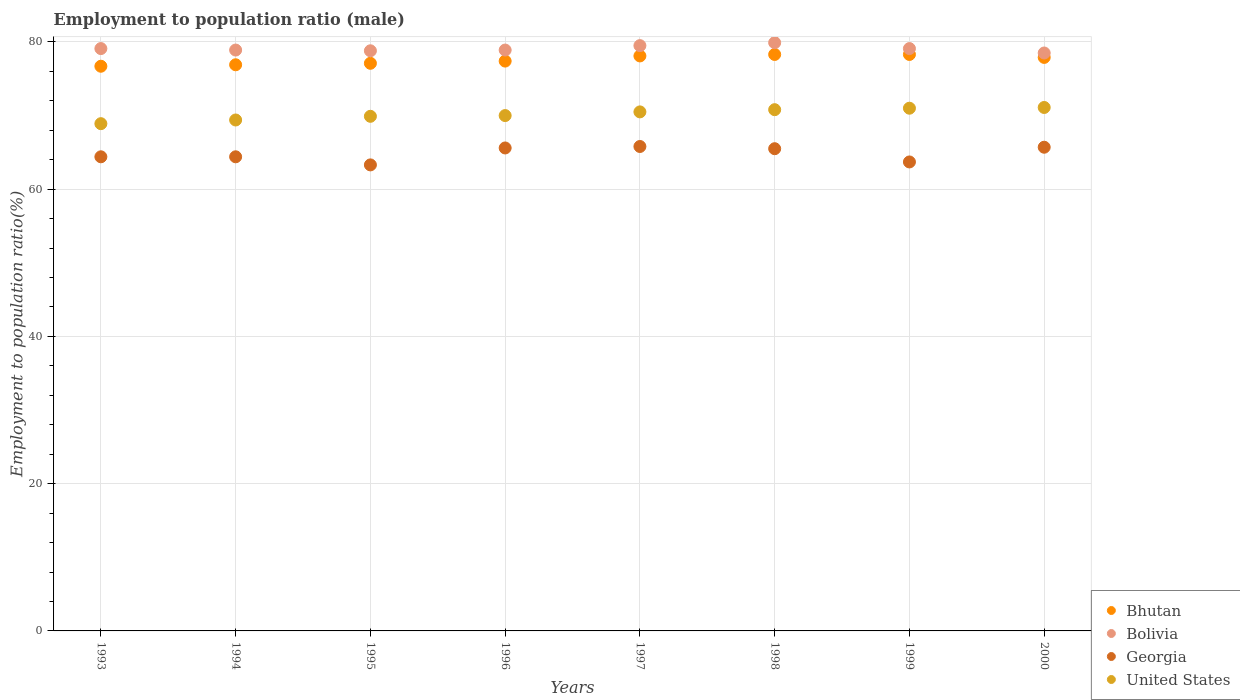How many different coloured dotlines are there?
Your answer should be compact. 4. What is the employment to population ratio in United States in 1996?
Your response must be concise. 70. Across all years, what is the maximum employment to population ratio in United States?
Your answer should be compact. 71.1. Across all years, what is the minimum employment to population ratio in Georgia?
Ensure brevity in your answer.  63.3. What is the total employment to population ratio in Bolivia in the graph?
Keep it short and to the point. 632.7. What is the difference between the employment to population ratio in Georgia in 1996 and that in 2000?
Offer a very short reply. -0.1. What is the difference between the employment to population ratio in United States in 1999 and the employment to population ratio in Bhutan in 1996?
Your answer should be very brief. -6.4. What is the average employment to population ratio in Bolivia per year?
Your answer should be very brief. 79.09. In the year 1996, what is the difference between the employment to population ratio in Bolivia and employment to population ratio in Georgia?
Your answer should be compact. 13.3. What is the ratio of the employment to population ratio in United States in 1996 to that in 2000?
Ensure brevity in your answer.  0.98. What is the difference between the highest and the second highest employment to population ratio in Bolivia?
Ensure brevity in your answer.  0.4. What is the difference between the highest and the lowest employment to population ratio in United States?
Keep it short and to the point. 2.2. Is it the case that in every year, the sum of the employment to population ratio in Bolivia and employment to population ratio in United States  is greater than the sum of employment to population ratio in Georgia and employment to population ratio in Bhutan?
Keep it short and to the point. Yes. Does the employment to population ratio in Bhutan monotonically increase over the years?
Offer a very short reply. No. Is the employment to population ratio in Bolivia strictly greater than the employment to population ratio in Bhutan over the years?
Provide a succinct answer. Yes. Is the employment to population ratio in United States strictly less than the employment to population ratio in Bhutan over the years?
Make the answer very short. Yes. How many dotlines are there?
Your answer should be compact. 4. How many years are there in the graph?
Provide a succinct answer. 8. Does the graph contain any zero values?
Make the answer very short. No. Where does the legend appear in the graph?
Provide a short and direct response. Bottom right. How many legend labels are there?
Provide a succinct answer. 4. How are the legend labels stacked?
Give a very brief answer. Vertical. What is the title of the graph?
Keep it short and to the point. Employment to population ratio (male). What is the Employment to population ratio(%) of Bhutan in 1993?
Keep it short and to the point. 76.7. What is the Employment to population ratio(%) in Bolivia in 1993?
Make the answer very short. 79.1. What is the Employment to population ratio(%) in Georgia in 1993?
Your answer should be compact. 64.4. What is the Employment to population ratio(%) in United States in 1993?
Your answer should be compact. 68.9. What is the Employment to population ratio(%) in Bhutan in 1994?
Your answer should be very brief. 76.9. What is the Employment to population ratio(%) in Bolivia in 1994?
Ensure brevity in your answer.  78.9. What is the Employment to population ratio(%) of Georgia in 1994?
Keep it short and to the point. 64.4. What is the Employment to population ratio(%) of United States in 1994?
Offer a very short reply. 69.4. What is the Employment to population ratio(%) of Bhutan in 1995?
Make the answer very short. 77.1. What is the Employment to population ratio(%) in Bolivia in 1995?
Offer a terse response. 78.8. What is the Employment to population ratio(%) of Georgia in 1995?
Offer a terse response. 63.3. What is the Employment to population ratio(%) in United States in 1995?
Your answer should be compact. 69.9. What is the Employment to population ratio(%) in Bhutan in 1996?
Keep it short and to the point. 77.4. What is the Employment to population ratio(%) of Bolivia in 1996?
Offer a terse response. 78.9. What is the Employment to population ratio(%) in Georgia in 1996?
Offer a very short reply. 65.6. What is the Employment to population ratio(%) of Bhutan in 1997?
Ensure brevity in your answer.  78.1. What is the Employment to population ratio(%) of Bolivia in 1997?
Provide a succinct answer. 79.5. What is the Employment to population ratio(%) of Georgia in 1997?
Give a very brief answer. 65.8. What is the Employment to population ratio(%) of United States in 1997?
Give a very brief answer. 70.5. What is the Employment to population ratio(%) of Bhutan in 1998?
Keep it short and to the point. 78.3. What is the Employment to population ratio(%) in Bolivia in 1998?
Your response must be concise. 79.9. What is the Employment to population ratio(%) in Georgia in 1998?
Make the answer very short. 65.5. What is the Employment to population ratio(%) of United States in 1998?
Your answer should be very brief. 70.8. What is the Employment to population ratio(%) in Bhutan in 1999?
Keep it short and to the point. 78.3. What is the Employment to population ratio(%) of Bolivia in 1999?
Give a very brief answer. 79.1. What is the Employment to population ratio(%) in Georgia in 1999?
Offer a very short reply. 63.7. What is the Employment to population ratio(%) in Bhutan in 2000?
Offer a terse response. 77.9. What is the Employment to population ratio(%) of Bolivia in 2000?
Give a very brief answer. 78.5. What is the Employment to population ratio(%) in Georgia in 2000?
Your answer should be compact. 65.7. What is the Employment to population ratio(%) of United States in 2000?
Provide a short and direct response. 71.1. Across all years, what is the maximum Employment to population ratio(%) in Bhutan?
Provide a succinct answer. 78.3. Across all years, what is the maximum Employment to population ratio(%) of Bolivia?
Provide a short and direct response. 79.9. Across all years, what is the maximum Employment to population ratio(%) in Georgia?
Offer a terse response. 65.8. Across all years, what is the maximum Employment to population ratio(%) in United States?
Offer a terse response. 71.1. Across all years, what is the minimum Employment to population ratio(%) of Bhutan?
Make the answer very short. 76.7. Across all years, what is the minimum Employment to population ratio(%) of Bolivia?
Offer a terse response. 78.5. Across all years, what is the minimum Employment to population ratio(%) in Georgia?
Offer a very short reply. 63.3. Across all years, what is the minimum Employment to population ratio(%) in United States?
Make the answer very short. 68.9. What is the total Employment to population ratio(%) of Bhutan in the graph?
Give a very brief answer. 620.7. What is the total Employment to population ratio(%) in Bolivia in the graph?
Your answer should be compact. 632.7. What is the total Employment to population ratio(%) in Georgia in the graph?
Your response must be concise. 518.4. What is the total Employment to population ratio(%) of United States in the graph?
Make the answer very short. 561.6. What is the difference between the Employment to population ratio(%) of Georgia in 1993 and that in 1994?
Give a very brief answer. 0. What is the difference between the Employment to population ratio(%) in United States in 1993 and that in 1994?
Give a very brief answer. -0.5. What is the difference between the Employment to population ratio(%) in Bolivia in 1993 and that in 1995?
Provide a short and direct response. 0.3. What is the difference between the Employment to population ratio(%) of United States in 1993 and that in 1995?
Keep it short and to the point. -1. What is the difference between the Employment to population ratio(%) of Bolivia in 1993 and that in 1996?
Offer a terse response. 0.2. What is the difference between the Employment to population ratio(%) of Georgia in 1993 and that in 1996?
Your response must be concise. -1.2. What is the difference between the Employment to population ratio(%) of United States in 1993 and that in 1996?
Your answer should be very brief. -1.1. What is the difference between the Employment to population ratio(%) of Bolivia in 1993 and that in 1997?
Your answer should be very brief. -0.4. What is the difference between the Employment to population ratio(%) of Bolivia in 1993 and that in 1998?
Offer a very short reply. -0.8. What is the difference between the Employment to population ratio(%) of Bhutan in 1993 and that in 1999?
Provide a succinct answer. -1.6. What is the difference between the Employment to population ratio(%) in Georgia in 1993 and that in 1999?
Give a very brief answer. 0.7. What is the difference between the Employment to population ratio(%) of Bolivia in 1993 and that in 2000?
Ensure brevity in your answer.  0.6. What is the difference between the Employment to population ratio(%) of United States in 1993 and that in 2000?
Make the answer very short. -2.2. What is the difference between the Employment to population ratio(%) in Bhutan in 1994 and that in 1995?
Offer a very short reply. -0.2. What is the difference between the Employment to population ratio(%) in Georgia in 1994 and that in 1995?
Ensure brevity in your answer.  1.1. What is the difference between the Employment to population ratio(%) of Bhutan in 1994 and that in 1996?
Keep it short and to the point. -0.5. What is the difference between the Employment to population ratio(%) in United States in 1994 and that in 1996?
Offer a very short reply. -0.6. What is the difference between the Employment to population ratio(%) of Bhutan in 1994 and that in 1997?
Offer a terse response. -1.2. What is the difference between the Employment to population ratio(%) in Georgia in 1994 and that in 1997?
Provide a succinct answer. -1.4. What is the difference between the Employment to population ratio(%) of Bolivia in 1994 and that in 1998?
Your answer should be very brief. -1. What is the difference between the Employment to population ratio(%) of Bhutan in 1994 and that in 1999?
Ensure brevity in your answer.  -1.4. What is the difference between the Employment to population ratio(%) of Bhutan in 1995 and that in 1996?
Provide a succinct answer. -0.3. What is the difference between the Employment to population ratio(%) of Bolivia in 1995 and that in 1996?
Keep it short and to the point. -0.1. What is the difference between the Employment to population ratio(%) in Georgia in 1995 and that in 1996?
Your answer should be very brief. -2.3. What is the difference between the Employment to population ratio(%) of Georgia in 1995 and that in 1997?
Your answer should be compact. -2.5. What is the difference between the Employment to population ratio(%) in United States in 1995 and that in 1998?
Keep it short and to the point. -0.9. What is the difference between the Employment to population ratio(%) of Bhutan in 1995 and that in 1999?
Your answer should be compact. -1.2. What is the difference between the Employment to population ratio(%) of Georgia in 1995 and that in 1999?
Your response must be concise. -0.4. What is the difference between the Employment to population ratio(%) of Bolivia in 1995 and that in 2000?
Keep it short and to the point. 0.3. What is the difference between the Employment to population ratio(%) of United States in 1995 and that in 2000?
Offer a terse response. -1.2. What is the difference between the Employment to population ratio(%) in Bhutan in 1996 and that in 1997?
Ensure brevity in your answer.  -0.7. What is the difference between the Employment to population ratio(%) of Bolivia in 1996 and that in 1997?
Provide a succinct answer. -0.6. What is the difference between the Employment to population ratio(%) of Georgia in 1996 and that in 1997?
Offer a very short reply. -0.2. What is the difference between the Employment to population ratio(%) of United States in 1996 and that in 1997?
Your response must be concise. -0.5. What is the difference between the Employment to population ratio(%) in Bolivia in 1996 and that in 1998?
Keep it short and to the point. -1. What is the difference between the Employment to population ratio(%) in Georgia in 1996 and that in 1998?
Offer a terse response. 0.1. What is the difference between the Employment to population ratio(%) in United States in 1996 and that in 1998?
Your response must be concise. -0.8. What is the difference between the Employment to population ratio(%) in Bolivia in 1996 and that in 1999?
Provide a succinct answer. -0.2. What is the difference between the Employment to population ratio(%) in Bolivia in 1996 and that in 2000?
Your response must be concise. 0.4. What is the difference between the Employment to population ratio(%) of United States in 1996 and that in 2000?
Provide a succinct answer. -1.1. What is the difference between the Employment to population ratio(%) of Bolivia in 1997 and that in 1998?
Your response must be concise. -0.4. What is the difference between the Employment to population ratio(%) of Bhutan in 1997 and that in 1999?
Give a very brief answer. -0.2. What is the difference between the Employment to population ratio(%) in Georgia in 1997 and that in 2000?
Provide a succinct answer. 0.1. What is the difference between the Employment to population ratio(%) in United States in 1997 and that in 2000?
Ensure brevity in your answer.  -0.6. What is the difference between the Employment to population ratio(%) of Bolivia in 1998 and that in 1999?
Your response must be concise. 0.8. What is the difference between the Employment to population ratio(%) of Georgia in 1998 and that in 1999?
Give a very brief answer. 1.8. What is the difference between the Employment to population ratio(%) of United States in 1998 and that in 2000?
Keep it short and to the point. -0.3. What is the difference between the Employment to population ratio(%) of Bhutan in 1999 and that in 2000?
Offer a terse response. 0.4. What is the difference between the Employment to population ratio(%) of Bolivia in 1999 and that in 2000?
Provide a succinct answer. 0.6. What is the difference between the Employment to population ratio(%) in United States in 1999 and that in 2000?
Your answer should be very brief. -0.1. What is the difference between the Employment to population ratio(%) in Bhutan in 1993 and the Employment to population ratio(%) in Georgia in 1994?
Keep it short and to the point. 12.3. What is the difference between the Employment to population ratio(%) of Bhutan in 1993 and the Employment to population ratio(%) of United States in 1994?
Provide a short and direct response. 7.3. What is the difference between the Employment to population ratio(%) of Georgia in 1993 and the Employment to population ratio(%) of United States in 1994?
Offer a terse response. -5. What is the difference between the Employment to population ratio(%) of Bhutan in 1993 and the Employment to population ratio(%) of Georgia in 1995?
Make the answer very short. 13.4. What is the difference between the Employment to population ratio(%) of Bolivia in 1993 and the Employment to population ratio(%) of Georgia in 1995?
Make the answer very short. 15.8. What is the difference between the Employment to population ratio(%) in Georgia in 1993 and the Employment to population ratio(%) in United States in 1995?
Your answer should be compact. -5.5. What is the difference between the Employment to population ratio(%) of Bhutan in 1993 and the Employment to population ratio(%) of Bolivia in 1996?
Your answer should be very brief. -2.2. What is the difference between the Employment to population ratio(%) in Bhutan in 1993 and the Employment to population ratio(%) in Georgia in 1996?
Provide a short and direct response. 11.1. What is the difference between the Employment to population ratio(%) in Bhutan in 1993 and the Employment to population ratio(%) in United States in 1996?
Give a very brief answer. 6.7. What is the difference between the Employment to population ratio(%) in Bolivia in 1993 and the Employment to population ratio(%) in United States in 1996?
Your answer should be compact. 9.1. What is the difference between the Employment to population ratio(%) of Bhutan in 1993 and the Employment to population ratio(%) of Bolivia in 1997?
Offer a very short reply. -2.8. What is the difference between the Employment to population ratio(%) of Bhutan in 1993 and the Employment to population ratio(%) of Georgia in 1997?
Give a very brief answer. 10.9. What is the difference between the Employment to population ratio(%) in Bhutan in 1993 and the Employment to population ratio(%) in United States in 1997?
Keep it short and to the point. 6.2. What is the difference between the Employment to population ratio(%) of Bolivia in 1993 and the Employment to population ratio(%) of United States in 1997?
Keep it short and to the point. 8.6. What is the difference between the Employment to population ratio(%) of Georgia in 1993 and the Employment to population ratio(%) of United States in 1997?
Provide a succinct answer. -6.1. What is the difference between the Employment to population ratio(%) of Bhutan in 1993 and the Employment to population ratio(%) of Georgia in 1998?
Give a very brief answer. 11.2. What is the difference between the Employment to population ratio(%) of Bhutan in 1993 and the Employment to population ratio(%) of United States in 1998?
Your answer should be compact. 5.9. What is the difference between the Employment to population ratio(%) in Bolivia in 1993 and the Employment to population ratio(%) in Georgia in 1998?
Provide a short and direct response. 13.6. What is the difference between the Employment to population ratio(%) of Bolivia in 1993 and the Employment to population ratio(%) of United States in 1998?
Provide a succinct answer. 8.3. What is the difference between the Employment to population ratio(%) of Bhutan in 1993 and the Employment to population ratio(%) of Bolivia in 1999?
Your response must be concise. -2.4. What is the difference between the Employment to population ratio(%) of Bhutan in 1993 and the Employment to population ratio(%) of United States in 1999?
Your answer should be very brief. 5.7. What is the difference between the Employment to population ratio(%) in Bolivia in 1993 and the Employment to population ratio(%) in Georgia in 1999?
Offer a terse response. 15.4. What is the difference between the Employment to population ratio(%) in Georgia in 1993 and the Employment to population ratio(%) in United States in 1999?
Provide a succinct answer. -6.6. What is the difference between the Employment to population ratio(%) in Bhutan in 1993 and the Employment to population ratio(%) in Bolivia in 2000?
Your answer should be very brief. -1.8. What is the difference between the Employment to population ratio(%) in Bhutan in 1993 and the Employment to population ratio(%) in Georgia in 2000?
Provide a succinct answer. 11. What is the difference between the Employment to population ratio(%) of Bhutan in 1993 and the Employment to population ratio(%) of United States in 2000?
Make the answer very short. 5.6. What is the difference between the Employment to population ratio(%) in Bolivia in 1993 and the Employment to population ratio(%) in Georgia in 2000?
Give a very brief answer. 13.4. What is the difference between the Employment to population ratio(%) of Georgia in 1993 and the Employment to population ratio(%) of United States in 2000?
Your answer should be compact. -6.7. What is the difference between the Employment to population ratio(%) in Bhutan in 1994 and the Employment to population ratio(%) in Bolivia in 1995?
Your answer should be very brief. -1.9. What is the difference between the Employment to population ratio(%) in Bhutan in 1994 and the Employment to population ratio(%) in Georgia in 1995?
Offer a terse response. 13.6. What is the difference between the Employment to population ratio(%) in Bhutan in 1994 and the Employment to population ratio(%) in United States in 1995?
Provide a short and direct response. 7. What is the difference between the Employment to population ratio(%) in Bolivia in 1994 and the Employment to population ratio(%) in Georgia in 1995?
Keep it short and to the point. 15.6. What is the difference between the Employment to population ratio(%) in Bolivia in 1994 and the Employment to population ratio(%) in United States in 1995?
Provide a succinct answer. 9. What is the difference between the Employment to population ratio(%) in Bhutan in 1994 and the Employment to population ratio(%) in Bolivia in 1996?
Provide a succinct answer. -2. What is the difference between the Employment to population ratio(%) in Bhutan in 1994 and the Employment to population ratio(%) in Georgia in 1996?
Give a very brief answer. 11.3. What is the difference between the Employment to population ratio(%) in Bhutan in 1994 and the Employment to population ratio(%) in United States in 1996?
Make the answer very short. 6.9. What is the difference between the Employment to population ratio(%) in Bhutan in 1994 and the Employment to population ratio(%) in Bolivia in 1997?
Your response must be concise. -2.6. What is the difference between the Employment to population ratio(%) in Bhutan in 1994 and the Employment to population ratio(%) in Georgia in 1997?
Your answer should be compact. 11.1. What is the difference between the Employment to population ratio(%) of Bhutan in 1994 and the Employment to population ratio(%) of United States in 1997?
Offer a terse response. 6.4. What is the difference between the Employment to population ratio(%) in Bolivia in 1994 and the Employment to population ratio(%) in United States in 1997?
Keep it short and to the point. 8.4. What is the difference between the Employment to population ratio(%) of Bhutan in 1994 and the Employment to population ratio(%) of Georgia in 1998?
Your answer should be very brief. 11.4. What is the difference between the Employment to population ratio(%) in Georgia in 1994 and the Employment to population ratio(%) in United States in 1998?
Offer a very short reply. -6.4. What is the difference between the Employment to population ratio(%) of Bhutan in 1994 and the Employment to population ratio(%) of Bolivia in 1999?
Keep it short and to the point. -2.2. What is the difference between the Employment to population ratio(%) in Bhutan in 1994 and the Employment to population ratio(%) in Georgia in 1999?
Your answer should be compact. 13.2. What is the difference between the Employment to population ratio(%) of Bhutan in 1994 and the Employment to population ratio(%) of United States in 1999?
Provide a short and direct response. 5.9. What is the difference between the Employment to population ratio(%) of Bolivia in 1994 and the Employment to population ratio(%) of Georgia in 1999?
Your response must be concise. 15.2. What is the difference between the Employment to population ratio(%) in Bhutan in 1994 and the Employment to population ratio(%) in Bolivia in 2000?
Ensure brevity in your answer.  -1.6. What is the difference between the Employment to population ratio(%) in Bhutan in 1994 and the Employment to population ratio(%) in United States in 2000?
Give a very brief answer. 5.8. What is the difference between the Employment to population ratio(%) in Bolivia in 1994 and the Employment to population ratio(%) in Georgia in 2000?
Offer a very short reply. 13.2. What is the difference between the Employment to population ratio(%) in Georgia in 1994 and the Employment to population ratio(%) in United States in 2000?
Provide a succinct answer. -6.7. What is the difference between the Employment to population ratio(%) of Bhutan in 1995 and the Employment to population ratio(%) of Georgia in 1996?
Your answer should be very brief. 11.5. What is the difference between the Employment to population ratio(%) of Bolivia in 1995 and the Employment to population ratio(%) of United States in 1996?
Your answer should be very brief. 8.8. What is the difference between the Employment to population ratio(%) of Georgia in 1995 and the Employment to population ratio(%) of United States in 1996?
Your answer should be compact. -6.7. What is the difference between the Employment to population ratio(%) of Bhutan in 1995 and the Employment to population ratio(%) of Georgia in 1997?
Your answer should be very brief. 11.3. What is the difference between the Employment to population ratio(%) in Bhutan in 1995 and the Employment to population ratio(%) in United States in 1998?
Give a very brief answer. 6.3. What is the difference between the Employment to population ratio(%) of Bolivia in 1995 and the Employment to population ratio(%) of United States in 1998?
Your answer should be compact. 8. What is the difference between the Employment to population ratio(%) in Bolivia in 1995 and the Employment to population ratio(%) in United States in 1999?
Provide a succinct answer. 7.8. What is the difference between the Employment to population ratio(%) of Georgia in 1995 and the Employment to population ratio(%) of United States in 1999?
Provide a succinct answer. -7.7. What is the difference between the Employment to population ratio(%) of Bhutan in 1995 and the Employment to population ratio(%) of United States in 2000?
Give a very brief answer. 6. What is the difference between the Employment to population ratio(%) in Bolivia in 1995 and the Employment to population ratio(%) in Georgia in 2000?
Your answer should be very brief. 13.1. What is the difference between the Employment to population ratio(%) in Bolivia in 1995 and the Employment to population ratio(%) in United States in 2000?
Keep it short and to the point. 7.7. What is the difference between the Employment to population ratio(%) of Georgia in 1995 and the Employment to population ratio(%) of United States in 2000?
Provide a short and direct response. -7.8. What is the difference between the Employment to population ratio(%) in Bhutan in 1996 and the Employment to population ratio(%) in United States in 1997?
Keep it short and to the point. 6.9. What is the difference between the Employment to population ratio(%) in Bolivia in 1996 and the Employment to population ratio(%) in Georgia in 1997?
Ensure brevity in your answer.  13.1. What is the difference between the Employment to population ratio(%) of Bolivia in 1996 and the Employment to population ratio(%) of United States in 1997?
Offer a terse response. 8.4. What is the difference between the Employment to population ratio(%) of Bhutan in 1996 and the Employment to population ratio(%) of United States in 1998?
Provide a succinct answer. 6.6. What is the difference between the Employment to population ratio(%) in Bolivia in 1996 and the Employment to population ratio(%) in Georgia in 1998?
Your response must be concise. 13.4. What is the difference between the Employment to population ratio(%) of Bolivia in 1996 and the Employment to population ratio(%) of United States in 1998?
Give a very brief answer. 8.1. What is the difference between the Employment to population ratio(%) in Bhutan in 1996 and the Employment to population ratio(%) in Bolivia in 1999?
Give a very brief answer. -1.7. What is the difference between the Employment to population ratio(%) of Bhutan in 1996 and the Employment to population ratio(%) of Georgia in 1999?
Your answer should be compact. 13.7. What is the difference between the Employment to population ratio(%) in Bolivia in 1996 and the Employment to population ratio(%) in United States in 1999?
Provide a short and direct response. 7.9. What is the difference between the Employment to population ratio(%) of Georgia in 1996 and the Employment to population ratio(%) of United States in 1999?
Your answer should be compact. -5.4. What is the difference between the Employment to population ratio(%) of Bhutan in 1996 and the Employment to population ratio(%) of Bolivia in 2000?
Give a very brief answer. -1.1. What is the difference between the Employment to population ratio(%) in Bhutan in 1996 and the Employment to population ratio(%) in United States in 2000?
Provide a succinct answer. 6.3. What is the difference between the Employment to population ratio(%) in Bolivia in 1996 and the Employment to population ratio(%) in Georgia in 2000?
Your response must be concise. 13.2. What is the difference between the Employment to population ratio(%) in Georgia in 1996 and the Employment to population ratio(%) in United States in 2000?
Your answer should be very brief. -5.5. What is the difference between the Employment to population ratio(%) of Bhutan in 1997 and the Employment to population ratio(%) of Bolivia in 1998?
Your answer should be very brief. -1.8. What is the difference between the Employment to population ratio(%) in Bolivia in 1997 and the Employment to population ratio(%) in Georgia in 1998?
Provide a short and direct response. 14. What is the difference between the Employment to population ratio(%) of Bolivia in 1997 and the Employment to population ratio(%) of United States in 1998?
Provide a short and direct response. 8.7. What is the difference between the Employment to population ratio(%) in Bhutan in 1997 and the Employment to population ratio(%) in Bolivia in 1999?
Your answer should be compact. -1. What is the difference between the Employment to population ratio(%) of Bhutan in 1997 and the Employment to population ratio(%) of Georgia in 1999?
Your answer should be compact. 14.4. What is the difference between the Employment to population ratio(%) of Bhutan in 1997 and the Employment to population ratio(%) of United States in 1999?
Your answer should be very brief. 7.1. What is the difference between the Employment to population ratio(%) in Bolivia in 1997 and the Employment to population ratio(%) in United States in 1999?
Keep it short and to the point. 8.5. What is the difference between the Employment to population ratio(%) in Georgia in 1997 and the Employment to population ratio(%) in United States in 1999?
Make the answer very short. -5.2. What is the difference between the Employment to population ratio(%) in Bhutan in 1997 and the Employment to population ratio(%) in Bolivia in 2000?
Provide a short and direct response. -0.4. What is the difference between the Employment to population ratio(%) in Bhutan in 1997 and the Employment to population ratio(%) in Georgia in 2000?
Offer a very short reply. 12.4. What is the difference between the Employment to population ratio(%) in Bhutan in 1997 and the Employment to population ratio(%) in United States in 2000?
Give a very brief answer. 7. What is the difference between the Employment to population ratio(%) of Bolivia in 1997 and the Employment to population ratio(%) of United States in 2000?
Your answer should be very brief. 8.4. What is the difference between the Employment to population ratio(%) in Georgia in 1997 and the Employment to population ratio(%) in United States in 2000?
Provide a succinct answer. -5.3. What is the difference between the Employment to population ratio(%) of Bhutan in 1998 and the Employment to population ratio(%) of Georgia in 1999?
Ensure brevity in your answer.  14.6. What is the difference between the Employment to population ratio(%) in Bhutan in 1998 and the Employment to population ratio(%) in United States in 1999?
Provide a succinct answer. 7.3. What is the difference between the Employment to population ratio(%) of Bolivia in 1998 and the Employment to population ratio(%) of Georgia in 1999?
Give a very brief answer. 16.2. What is the difference between the Employment to population ratio(%) of Bolivia in 1998 and the Employment to population ratio(%) of United States in 1999?
Offer a very short reply. 8.9. What is the difference between the Employment to population ratio(%) of Bhutan in 1998 and the Employment to population ratio(%) of Bolivia in 2000?
Your answer should be compact. -0.2. What is the difference between the Employment to population ratio(%) in Bhutan in 1998 and the Employment to population ratio(%) in United States in 2000?
Provide a short and direct response. 7.2. What is the difference between the Employment to population ratio(%) in Bolivia in 1998 and the Employment to population ratio(%) in United States in 2000?
Offer a terse response. 8.8. What is the difference between the Employment to population ratio(%) of Bhutan in 1999 and the Employment to population ratio(%) of Bolivia in 2000?
Keep it short and to the point. -0.2. What is the difference between the Employment to population ratio(%) of Bhutan in 1999 and the Employment to population ratio(%) of United States in 2000?
Ensure brevity in your answer.  7.2. What is the difference between the Employment to population ratio(%) in Bolivia in 1999 and the Employment to population ratio(%) in United States in 2000?
Your answer should be compact. 8. What is the difference between the Employment to population ratio(%) of Georgia in 1999 and the Employment to population ratio(%) of United States in 2000?
Provide a succinct answer. -7.4. What is the average Employment to population ratio(%) of Bhutan per year?
Your response must be concise. 77.59. What is the average Employment to population ratio(%) in Bolivia per year?
Provide a short and direct response. 79.09. What is the average Employment to population ratio(%) of Georgia per year?
Provide a short and direct response. 64.8. What is the average Employment to population ratio(%) in United States per year?
Give a very brief answer. 70.2. In the year 1993, what is the difference between the Employment to population ratio(%) in Bhutan and Employment to population ratio(%) in Bolivia?
Offer a very short reply. -2.4. In the year 1993, what is the difference between the Employment to population ratio(%) of Bhutan and Employment to population ratio(%) of United States?
Offer a very short reply. 7.8. In the year 1993, what is the difference between the Employment to population ratio(%) in Bolivia and Employment to population ratio(%) in United States?
Make the answer very short. 10.2. In the year 1993, what is the difference between the Employment to population ratio(%) in Georgia and Employment to population ratio(%) in United States?
Make the answer very short. -4.5. In the year 1994, what is the difference between the Employment to population ratio(%) of Bolivia and Employment to population ratio(%) of Georgia?
Keep it short and to the point. 14.5. In the year 1994, what is the difference between the Employment to population ratio(%) of Georgia and Employment to population ratio(%) of United States?
Your answer should be very brief. -5. In the year 1995, what is the difference between the Employment to population ratio(%) in Bhutan and Employment to population ratio(%) in Bolivia?
Provide a short and direct response. -1.7. In the year 1995, what is the difference between the Employment to population ratio(%) in Bhutan and Employment to population ratio(%) in United States?
Provide a short and direct response. 7.2. In the year 1996, what is the difference between the Employment to population ratio(%) of Bhutan and Employment to population ratio(%) of Georgia?
Give a very brief answer. 11.8. In the year 1996, what is the difference between the Employment to population ratio(%) of Bolivia and Employment to population ratio(%) of United States?
Keep it short and to the point. 8.9. In the year 1997, what is the difference between the Employment to population ratio(%) of Bhutan and Employment to population ratio(%) of Bolivia?
Provide a succinct answer. -1.4. In the year 1997, what is the difference between the Employment to population ratio(%) of Bhutan and Employment to population ratio(%) of Georgia?
Ensure brevity in your answer.  12.3. In the year 1997, what is the difference between the Employment to population ratio(%) in Bolivia and Employment to population ratio(%) in United States?
Ensure brevity in your answer.  9. In the year 1998, what is the difference between the Employment to population ratio(%) of Bhutan and Employment to population ratio(%) of Bolivia?
Make the answer very short. -1.6. In the year 1998, what is the difference between the Employment to population ratio(%) in Bolivia and Employment to population ratio(%) in Georgia?
Give a very brief answer. 14.4. In the year 1998, what is the difference between the Employment to population ratio(%) of Georgia and Employment to population ratio(%) of United States?
Your response must be concise. -5.3. In the year 1999, what is the difference between the Employment to population ratio(%) in Bhutan and Employment to population ratio(%) in United States?
Make the answer very short. 7.3. In the year 1999, what is the difference between the Employment to population ratio(%) in Bolivia and Employment to population ratio(%) in United States?
Your answer should be compact. 8.1. In the year 1999, what is the difference between the Employment to population ratio(%) of Georgia and Employment to population ratio(%) of United States?
Make the answer very short. -7.3. In the year 2000, what is the difference between the Employment to population ratio(%) in Bhutan and Employment to population ratio(%) in Georgia?
Offer a very short reply. 12.2. In the year 2000, what is the difference between the Employment to population ratio(%) of Bhutan and Employment to population ratio(%) of United States?
Your answer should be compact. 6.8. In the year 2000, what is the difference between the Employment to population ratio(%) of Bolivia and Employment to population ratio(%) of United States?
Keep it short and to the point. 7.4. In the year 2000, what is the difference between the Employment to population ratio(%) in Georgia and Employment to population ratio(%) in United States?
Offer a very short reply. -5.4. What is the ratio of the Employment to population ratio(%) of Bolivia in 1993 to that in 1994?
Your answer should be very brief. 1. What is the ratio of the Employment to population ratio(%) in United States in 1993 to that in 1994?
Provide a short and direct response. 0.99. What is the ratio of the Employment to population ratio(%) in Bhutan in 1993 to that in 1995?
Provide a succinct answer. 0.99. What is the ratio of the Employment to population ratio(%) of Georgia in 1993 to that in 1995?
Provide a short and direct response. 1.02. What is the ratio of the Employment to population ratio(%) in United States in 1993 to that in 1995?
Offer a terse response. 0.99. What is the ratio of the Employment to population ratio(%) of Bhutan in 1993 to that in 1996?
Give a very brief answer. 0.99. What is the ratio of the Employment to population ratio(%) in Georgia in 1993 to that in 1996?
Provide a succinct answer. 0.98. What is the ratio of the Employment to population ratio(%) in United States in 1993 to that in 1996?
Your response must be concise. 0.98. What is the ratio of the Employment to population ratio(%) in Bhutan in 1993 to that in 1997?
Your response must be concise. 0.98. What is the ratio of the Employment to population ratio(%) of Bolivia in 1993 to that in 1997?
Ensure brevity in your answer.  0.99. What is the ratio of the Employment to population ratio(%) in Georgia in 1993 to that in 1997?
Ensure brevity in your answer.  0.98. What is the ratio of the Employment to population ratio(%) in United States in 1993 to that in 1997?
Your answer should be compact. 0.98. What is the ratio of the Employment to population ratio(%) of Bhutan in 1993 to that in 1998?
Offer a terse response. 0.98. What is the ratio of the Employment to population ratio(%) in Georgia in 1993 to that in 1998?
Your answer should be very brief. 0.98. What is the ratio of the Employment to population ratio(%) in United States in 1993 to that in 1998?
Keep it short and to the point. 0.97. What is the ratio of the Employment to population ratio(%) in Bhutan in 1993 to that in 1999?
Ensure brevity in your answer.  0.98. What is the ratio of the Employment to population ratio(%) of Bolivia in 1993 to that in 1999?
Your response must be concise. 1. What is the ratio of the Employment to population ratio(%) of United States in 1993 to that in 1999?
Provide a short and direct response. 0.97. What is the ratio of the Employment to population ratio(%) of Bhutan in 1993 to that in 2000?
Provide a short and direct response. 0.98. What is the ratio of the Employment to population ratio(%) of Bolivia in 1993 to that in 2000?
Give a very brief answer. 1.01. What is the ratio of the Employment to population ratio(%) in Georgia in 1993 to that in 2000?
Provide a short and direct response. 0.98. What is the ratio of the Employment to population ratio(%) in United States in 1993 to that in 2000?
Ensure brevity in your answer.  0.97. What is the ratio of the Employment to population ratio(%) of Georgia in 1994 to that in 1995?
Make the answer very short. 1.02. What is the ratio of the Employment to population ratio(%) in United States in 1994 to that in 1995?
Offer a terse response. 0.99. What is the ratio of the Employment to population ratio(%) of Bhutan in 1994 to that in 1996?
Ensure brevity in your answer.  0.99. What is the ratio of the Employment to population ratio(%) in Bolivia in 1994 to that in 1996?
Give a very brief answer. 1. What is the ratio of the Employment to population ratio(%) in Georgia in 1994 to that in 1996?
Give a very brief answer. 0.98. What is the ratio of the Employment to population ratio(%) of United States in 1994 to that in 1996?
Your answer should be compact. 0.99. What is the ratio of the Employment to population ratio(%) of Bhutan in 1994 to that in 1997?
Provide a succinct answer. 0.98. What is the ratio of the Employment to population ratio(%) of Georgia in 1994 to that in 1997?
Ensure brevity in your answer.  0.98. What is the ratio of the Employment to population ratio(%) in United States in 1994 to that in 1997?
Your answer should be compact. 0.98. What is the ratio of the Employment to population ratio(%) of Bhutan in 1994 to that in 1998?
Give a very brief answer. 0.98. What is the ratio of the Employment to population ratio(%) of Bolivia in 1994 to that in 1998?
Your answer should be compact. 0.99. What is the ratio of the Employment to population ratio(%) in Georgia in 1994 to that in 1998?
Offer a very short reply. 0.98. What is the ratio of the Employment to population ratio(%) in United States in 1994 to that in 1998?
Make the answer very short. 0.98. What is the ratio of the Employment to population ratio(%) of Bhutan in 1994 to that in 1999?
Provide a short and direct response. 0.98. What is the ratio of the Employment to population ratio(%) of United States in 1994 to that in 1999?
Your answer should be compact. 0.98. What is the ratio of the Employment to population ratio(%) in Bhutan in 1994 to that in 2000?
Make the answer very short. 0.99. What is the ratio of the Employment to population ratio(%) in Bolivia in 1994 to that in 2000?
Provide a short and direct response. 1.01. What is the ratio of the Employment to population ratio(%) in Georgia in 1994 to that in 2000?
Your answer should be compact. 0.98. What is the ratio of the Employment to population ratio(%) of United States in 1994 to that in 2000?
Provide a succinct answer. 0.98. What is the ratio of the Employment to population ratio(%) in Georgia in 1995 to that in 1996?
Keep it short and to the point. 0.96. What is the ratio of the Employment to population ratio(%) in Bhutan in 1995 to that in 1997?
Provide a short and direct response. 0.99. What is the ratio of the Employment to population ratio(%) in Bolivia in 1995 to that in 1997?
Keep it short and to the point. 0.99. What is the ratio of the Employment to population ratio(%) of Georgia in 1995 to that in 1997?
Keep it short and to the point. 0.96. What is the ratio of the Employment to population ratio(%) in United States in 1995 to that in 1997?
Your response must be concise. 0.99. What is the ratio of the Employment to population ratio(%) of Bhutan in 1995 to that in 1998?
Give a very brief answer. 0.98. What is the ratio of the Employment to population ratio(%) of Bolivia in 1995 to that in 1998?
Your answer should be compact. 0.99. What is the ratio of the Employment to population ratio(%) in Georgia in 1995 to that in 1998?
Offer a terse response. 0.97. What is the ratio of the Employment to population ratio(%) in United States in 1995 to that in 1998?
Provide a succinct answer. 0.99. What is the ratio of the Employment to population ratio(%) in Bhutan in 1995 to that in 1999?
Your response must be concise. 0.98. What is the ratio of the Employment to population ratio(%) in Bolivia in 1995 to that in 1999?
Ensure brevity in your answer.  1. What is the ratio of the Employment to population ratio(%) in Georgia in 1995 to that in 1999?
Offer a terse response. 0.99. What is the ratio of the Employment to population ratio(%) in United States in 1995 to that in 1999?
Your answer should be very brief. 0.98. What is the ratio of the Employment to population ratio(%) of Georgia in 1995 to that in 2000?
Provide a short and direct response. 0.96. What is the ratio of the Employment to population ratio(%) of United States in 1995 to that in 2000?
Keep it short and to the point. 0.98. What is the ratio of the Employment to population ratio(%) in Bhutan in 1996 to that in 1997?
Provide a succinct answer. 0.99. What is the ratio of the Employment to population ratio(%) of Georgia in 1996 to that in 1997?
Your response must be concise. 1. What is the ratio of the Employment to population ratio(%) in United States in 1996 to that in 1997?
Ensure brevity in your answer.  0.99. What is the ratio of the Employment to population ratio(%) of Bhutan in 1996 to that in 1998?
Provide a short and direct response. 0.99. What is the ratio of the Employment to population ratio(%) of Bolivia in 1996 to that in 1998?
Make the answer very short. 0.99. What is the ratio of the Employment to population ratio(%) of Georgia in 1996 to that in 1998?
Your answer should be very brief. 1. What is the ratio of the Employment to population ratio(%) of United States in 1996 to that in 1998?
Give a very brief answer. 0.99. What is the ratio of the Employment to population ratio(%) in Bhutan in 1996 to that in 1999?
Your answer should be compact. 0.99. What is the ratio of the Employment to population ratio(%) of Bolivia in 1996 to that in 1999?
Your answer should be compact. 1. What is the ratio of the Employment to population ratio(%) of Georgia in 1996 to that in 1999?
Make the answer very short. 1.03. What is the ratio of the Employment to population ratio(%) in United States in 1996 to that in 1999?
Your answer should be compact. 0.99. What is the ratio of the Employment to population ratio(%) of Bolivia in 1996 to that in 2000?
Ensure brevity in your answer.  1.01. What is the ratio of the Employment to population ratio(%) in United States in 1996 to that in 2000?
Your answer should be compact. 0.98. What is the ratio of the Employment to population ratio(%) in Georgia in 1997 to that in 1998?
Your response must be concise. 1. What is the ratio of the Employment to population ratio(%) of United States in 1997 to that in 1998?
Make the answer very short. 1. What is the ratio of the Employment to population ratio(%) in Bhutan in 1997 to that in 1999?
Keep it short and to the point. 1. What is the ratio of the Employment to population ratio(%) of Bolivia in 1997 to that in 1999?
Provide a succinct answer. 1.01. What is the ratio of the Employment to population ratio(%) in Georgia in 1997 to that in 1999?
Offer a very short reply. 1.03. What is the ratio of the Employment to population ratio(%) of United States in 1997 to that in 1999?
Keep it short and to the point. 0.99. What is the ratio of the Employment to population ratio(%) of Bhutan in 1997 to that in 2000?
Offer a terse response. 1. What is the ratio of the Employment to population ratio(%) of Bolivia in 1997 to that in 2000?
Offer a terse response. 1.01. What is the ratio of the Employment to population ratio(%) in United States in 1997 to that in 2000?
Offer a terse response. 0.99. What is the ratio of the Employment to population ratio(%) in Bhutan in 1998 to that in 1999?
Offer a terse response. 1. What is the ratio of the Employment to population ratio(%) in Georgia in 1998 to that in 1999?
Ensure brevity in your answer.  1.03. What is the ratio of the Employment to population ratio(%) in United States in 1998 to that in 1999?
Provide a succinct answer. 1. What is the ratio of the Employment to population ratio(%) in Bolivia in 1998 to that in 2000?
Offer a very short reply. 1.02. What is the ratio of the Employment to population ratio(%) of United States in 1998 to that in 2000?
Your answer should be compact. 1. What is the ratio of the Employment to population ratio(%) in Bhutan in 1999 to that in 2000?
Provide a succinct answer. 1.01. What is the ratio of the Employment to population ratio(%) in Bolivia in 1999 to that in 2000?
Provide a succinct answer. 1.01. What is the ratio of the Employment to population ratio(%) of Georgia in 1999 to that in 2000?
Offer a terse response. 0.97. What is the ratio of the Employment to population ratio(%) of United States in 1999 to that in 2000?
Your answer should be very brief. 1. What is the difference between the highest and the second highest Employment to population ratio(%) of Bolivia?
Your answer should be very brief. 0.4. What is the difference between the highest and the second highest Employment to population ratio(%) of United States?
Give a very brief answer. 0.1. What is the difference between the highest and the lowest Employment to population ratio(%) of Bolivia?
Ensure brevity in your answer.  1.4. What is the difference between the highest and the lowest Employment to population ratio(%) of Georgia?
Your response must be concise. 2.5. 